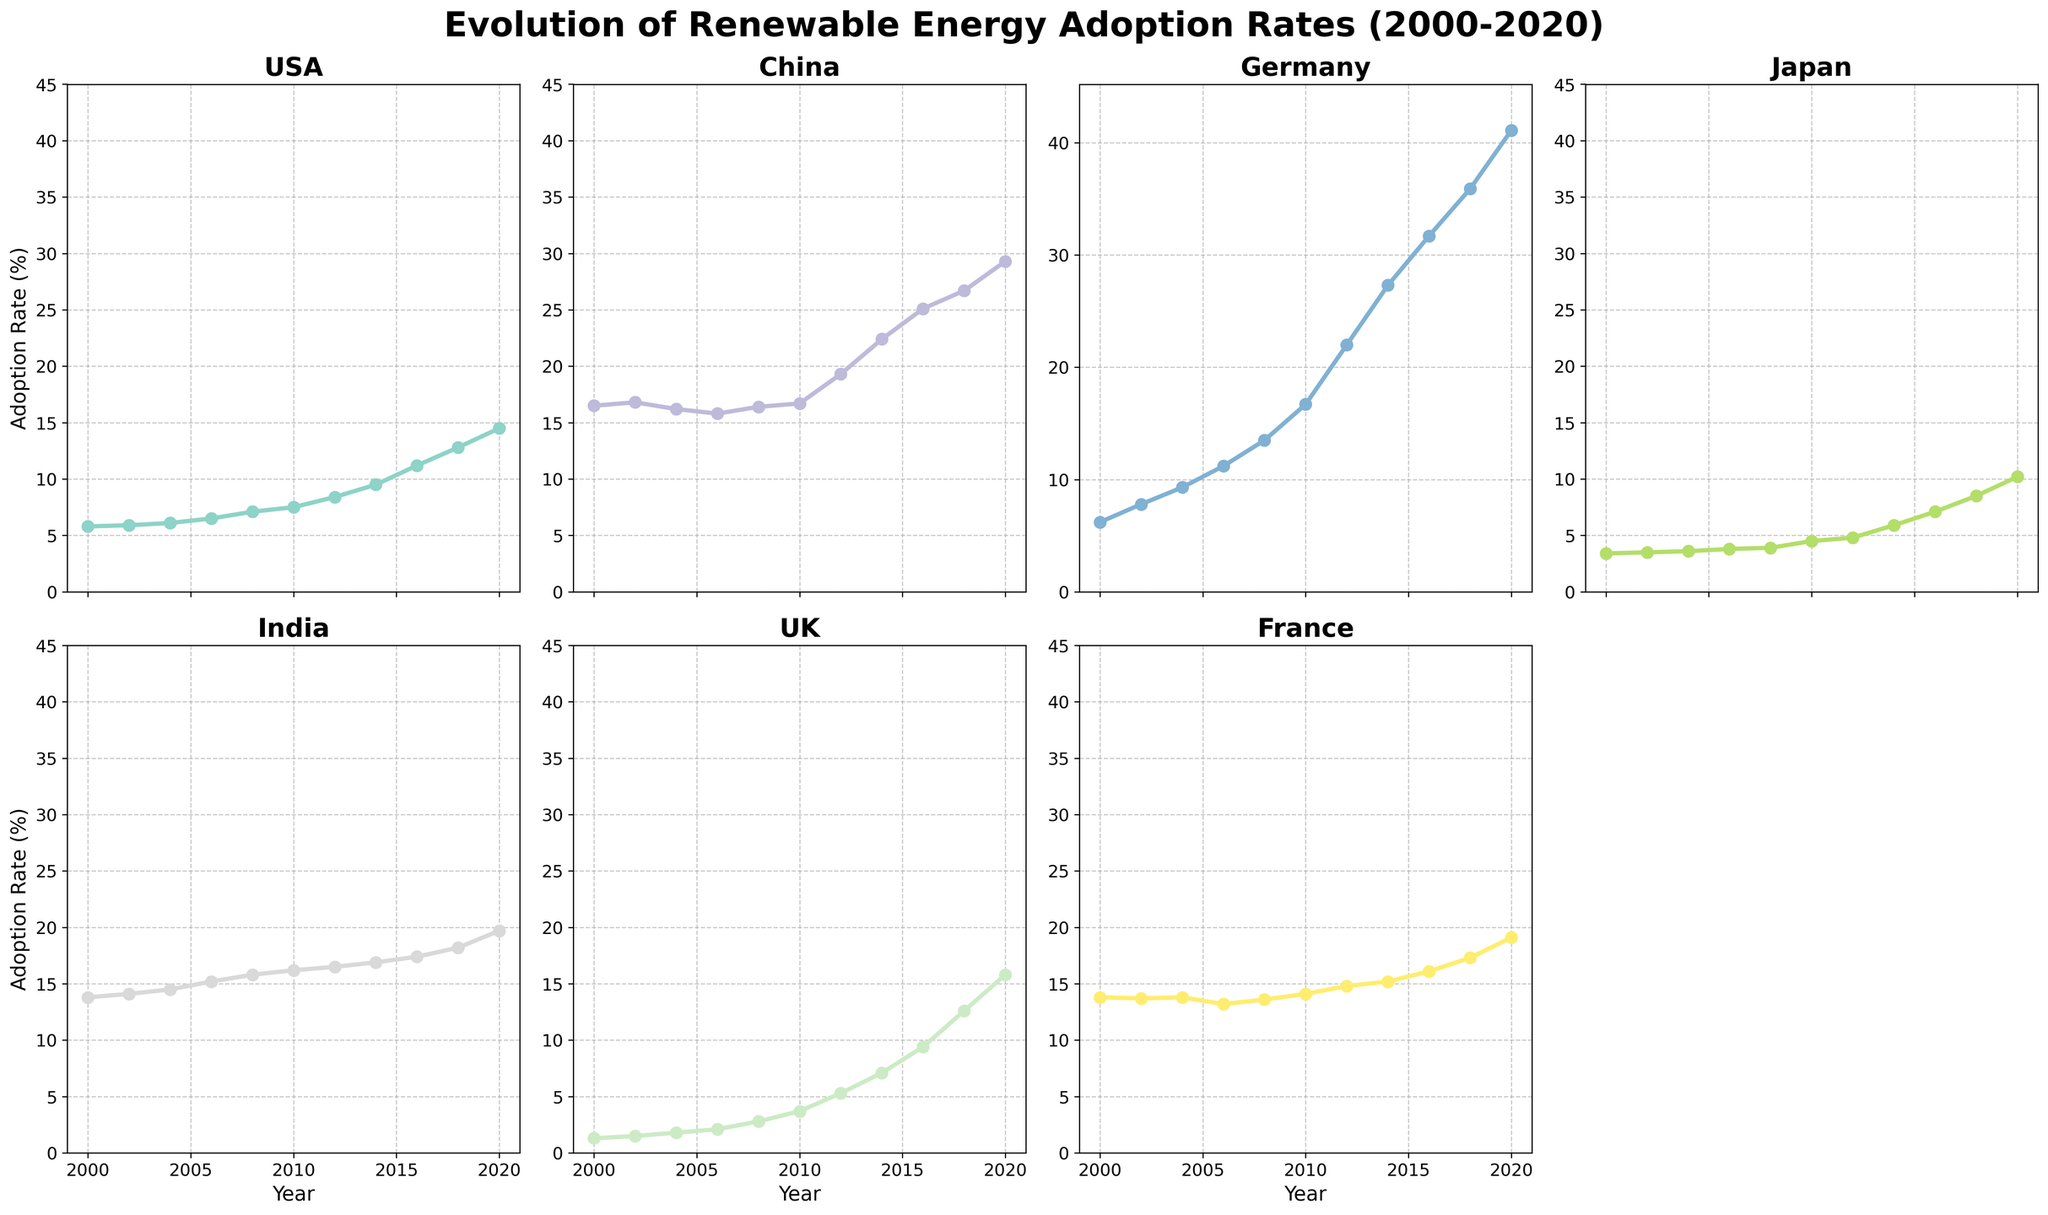What is the range of renewable energy adoption rates for Germany from 2000 to 2020? To find the range, look at the minimum and maximum values on Germany's subplot. The minimum is 6.2% in 2000, and the maximum is 41.1% in 2020. Subtract the minimum value from the maximum value. 41.1 - 6.2 = 34.9
Answer: 34.9% Which country had the highest renewable energy adoption rate in 2020? Check the data points for all countries in the year 2020. Germany has the highest value at 41.1%.
Answer: Germany Between which years did the USA see the most significant increase in renewable energy adoption rates? Look at the USA subplot and compare the slopes of line segments between points. The steepest increase occurs between 2018 (12.8%) and 2020 (14.5%). 14.5 - 12.8 = 1.7
Answer: 2018 to 2020 How many countries had more than a 15% adoption rate by 2020? Look at the data points for 2020 across all countries. The countries with more than 15% are USA, China, Germany, Japan, India, and UK. That's 6 countries.
Answer: 6 Which country had the least fluctuating renewable energy adoption rates between 2000-2020? Look at the changes in the slopes for each country over the specified period. The UK has steadily increasing rates with least variations as compared to others.
Answer: UK During which period did China have the least change in its adoption rate? Observe the China subplot to find where the line is most horizontal (i.e., minimal slope). Between 2004 (16.2%) and 2006 (15.8%), the change is 0.4, which is minimal.
Answer: 2004 to 2006 On average, how much did Japan's adoption rate increase per year between 2000 and 2020? To find the average yearly increase, take the difference in values from 2020 and 2000 for Japan and divide by the number of years (2020-2000 = 20 years). (10.2 - 3.4)/20 = 0.34
Answer: 0.34% Which country's renewable energy adoption rate rose above 10% last among the listed countries? Check each country's plot and identify the year their adoption rate first exceeds 10%. The USA crosses 10% in 2016, which is the latest compared to others.
Answer: USA If you sum the renewable energy adoption rates for France and the UK in 2010, what is the total? Find the rates for both countries in 2010: France (14.1%) + UK (3.7%) = 17.8%
Answer: 17.8% 